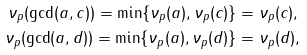Convert formula to latex. <formula><loc_0><loc_0><loc_500><loc_500>\nu _ { p } ( \gcd ( a , c ) ) = \min \{ \nu _ { p } ( a ) , \nu _ { p } ( c ) \} & = \nu _ { p } ( c ) , \\ \nu _ { p } ( \gcd ( a , d ) ) = \min \{ \nu _ { p } ( a ) , \nu _ { p } ( d ) \} & = \nu _ { p } ( d ) ,</formula> 